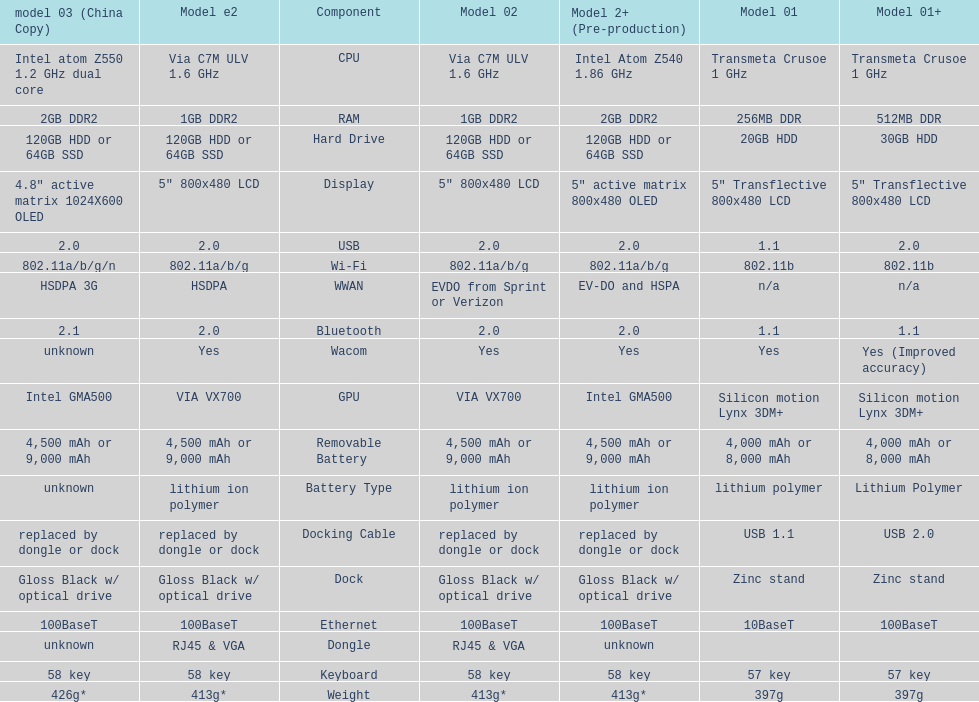The model 2 and the model 2e have what type of cpu? Via C7M ULV 1.6 GHz. 